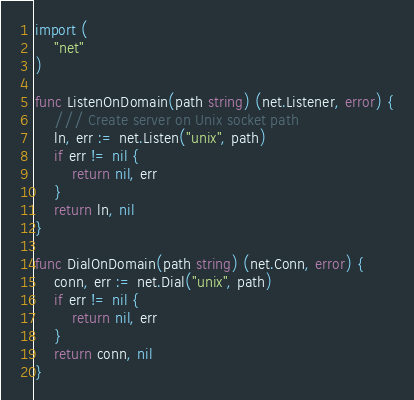<code> <loc_0><loc_0><loc_500><loc_500><_Go_>
import (
	"net"
)

func ListenOnDomain(path string) (net.Listener, error) {
	/// Create server on Unix socket path
	ln, err := net.Listen("unix", path)
	if err != nil {
		return nil, err
	}
	return ln, nil
}

func DialOnDomain(path string) (net.Conn, error) {
	conn, err := net.Dial("unix", path)
	if err != nil {
		return nil, err
	}
	return conn, nil
}
</code> 